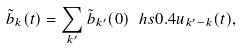<formula> <loc_0><loc_0><loc_500><loc_500>\tilde { b } _ { k } ( t ) = \sum _ { k ^ { \prime } } \tilde { b } _ { k ^ { \prime } } ( 0 ) \ h s { 0 . 4 } u _ { k ^ { \prime } - k } ( t ) ,</formula> 